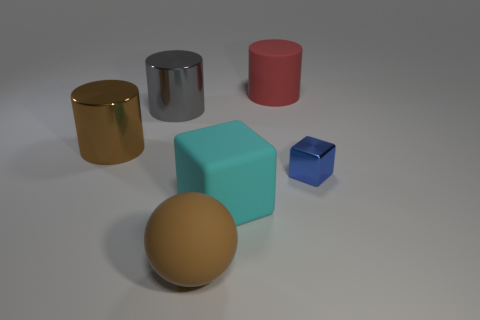Are there any green things made of the same material as the large gray cylinder?
Make the answer very short. No. There is a red object that is the same size as the brown metal cylinder; what is its material?
Offer a terse response. Rubber. How many brown matte things have the same shape as the big gray shiny object?
Make the answer very short. 0. What is the size of the red thing that is made of the same material as the big block?
Offer a very short reply. Large. What material is the cylinder that is left of the rubber block and on the right side of the brown cylinder?
Your response must be concise. Metal. What number of yellow metal cylinders have the same size as the cyan matte thing?
Provide a succinct answer. 0. What material is the big thing that is the same shape as the small object?
Ensure brevity in your answer.  Rubber. How many objects are either big cylinders right of the big brown ball or small blue shiny objects that are right of the big gray cylinder?
Make the answer very short. 2. There is a big cyan thing; is it the same shape as the small object in front of the gray object?
Your response must be concise. Yes. There is a matte thing on the right side of the cube that is to the left of the metallic object right of the large brown ball; what shape is it?
Provide a short and direct response. Cylinder. 